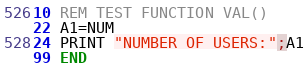Convert code to text. <code><loc_0><loc_0><loc_500><loc_500><_VisualBasic_>10 REM TEST FUNCTION VAL()
22 A1=NUM
24 PRINT "NUMBER OF USERS:";A1
99 END
</code> 